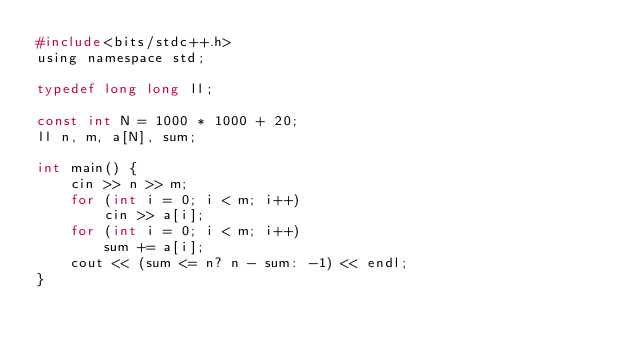Convert code to text. <code><loc_0><loc_0><loc_500><loc_500><_C_>#include<bits/stdc++.h>
using namespace std;

typedef long long ll;

const int N = 1000 * 1000 + 20;
ll n, m, a[N], sum;

int main() {
	cin >> n >> m;
    for (int i = 0; i < m; i++)
		cin >> a[i];
    for (int i = 0; i < m; i++)
		sum += a[i];
    cout << (sum <= n? n - sum: -1) << endl;
}</code> 